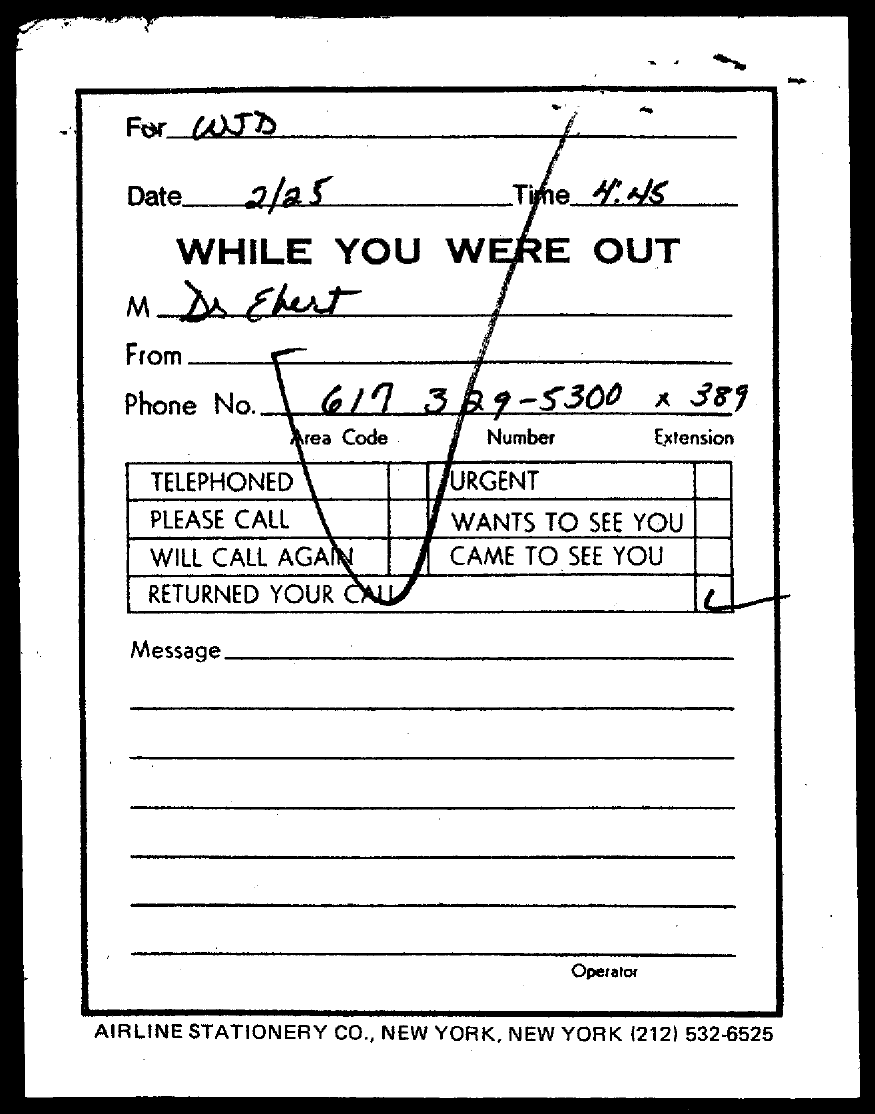List a handful of essential elements in this visual. The time is currently 4.45... The date is currently 2/25. The letter is addressed to "To Whom is this letter addressed to? WJD.. The phone number is 617 329-5300 x 389. 